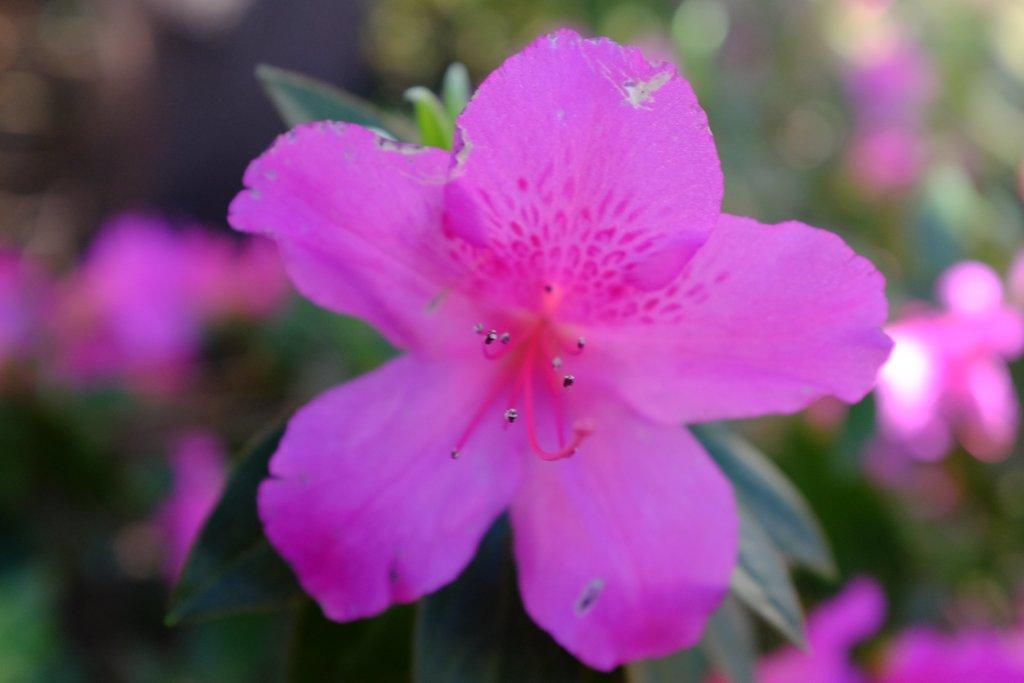What is the main subject of the image? The main subject of the image is a flower. Where is the flower located? The flower is on a plant. What type of zephyr is depicted on the canvas in the image? There is no canvas or zephyr present in the image; it features a flower on a plant. 